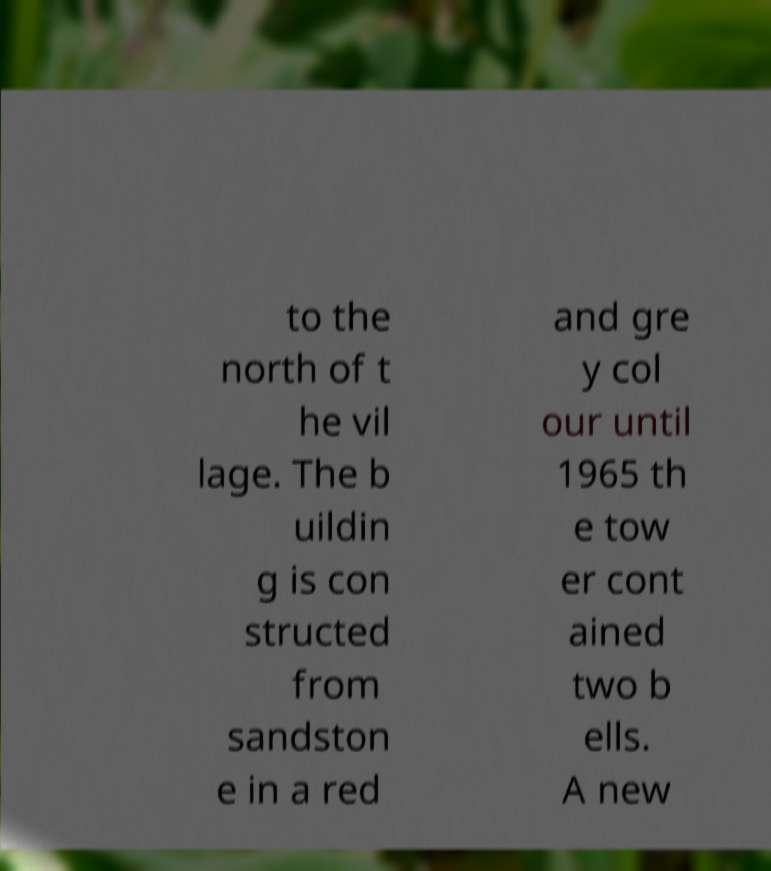Please identify and transcribe the text found in this image. to the north of t he vil lage. The b uildin g is con structed from sandston e in a red and gre y col our until 1965 th e tow er cont ained two b ells. A new 